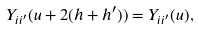Convert formula to latex. <formula><loc_0><loc_0><loc_500><loc_500>Y _ { i i ^ { \prime } } ( u + 2 ( h + h ^ { \prime } ) ) = Y _ { i i ^ { \prime } } ( u ) ,</formula> 